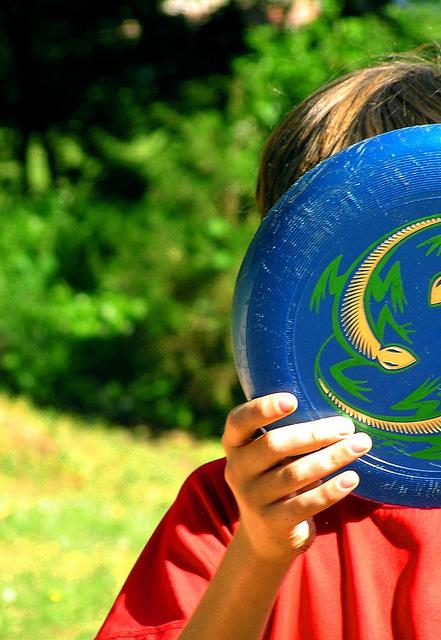What is the person holding?
Quick response, please. Frisbee. How many fingers are visible?
Answer briefly. 4. What animal is on the toy?
Write a very short answer. Lizard. 